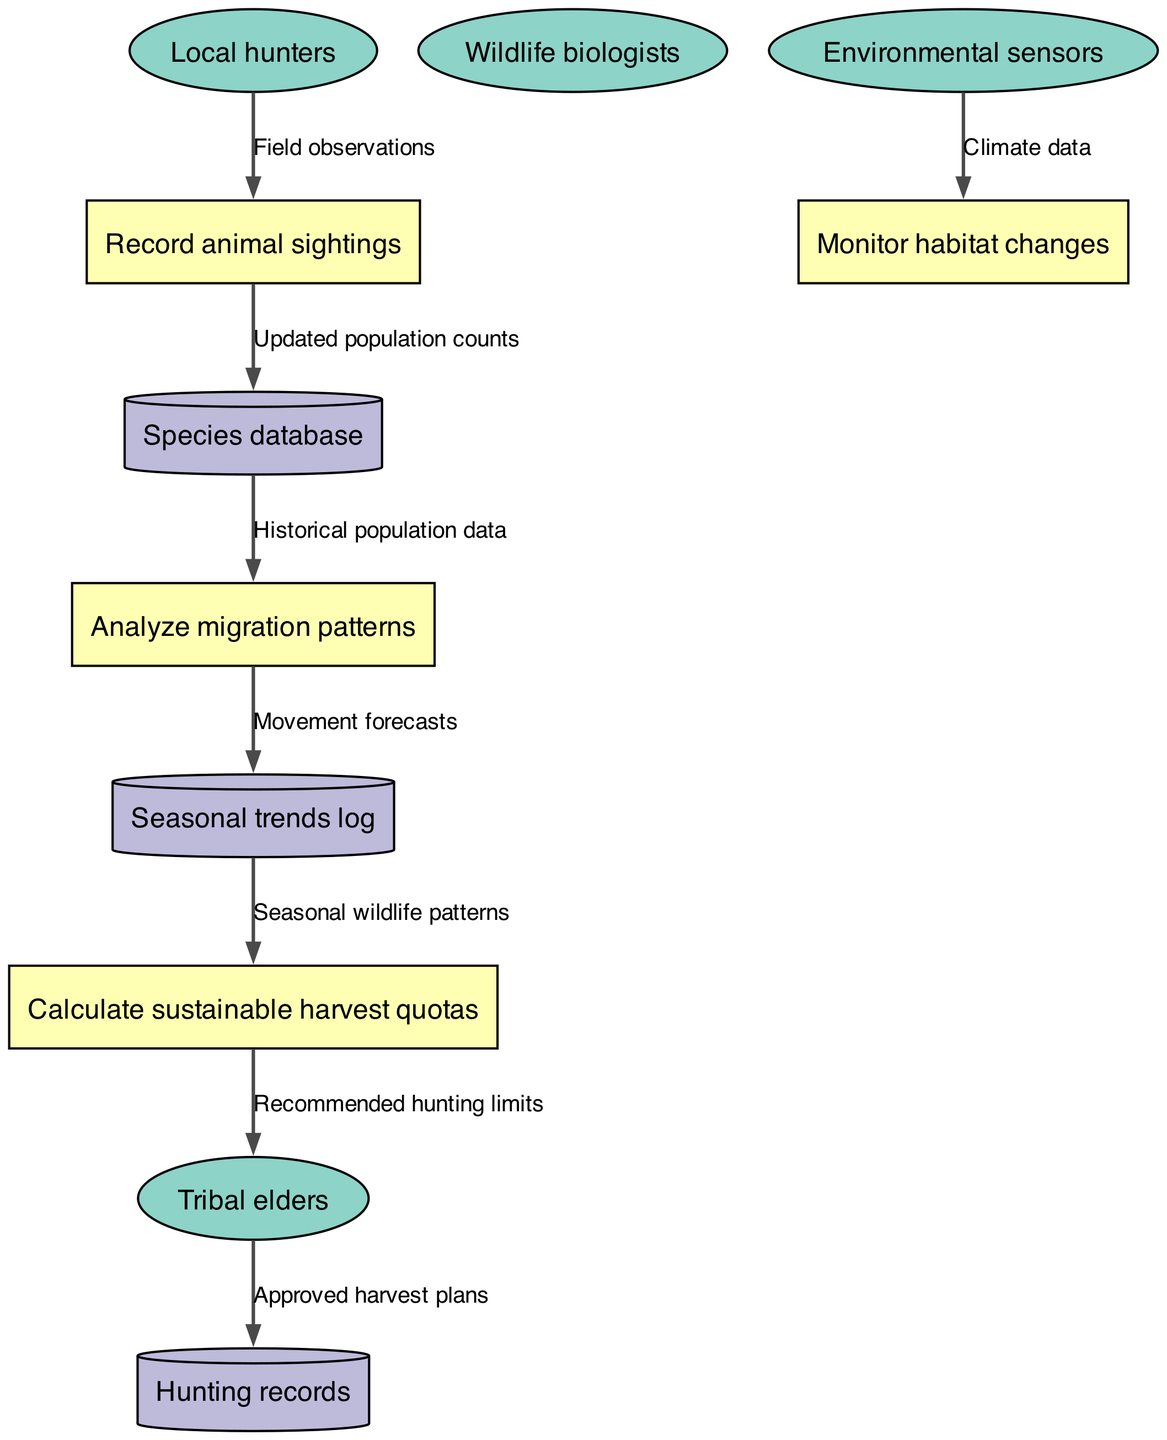What are the external entities in the diagram? The external entities are listed in the diagram. They include Local hunters, Tribal elders, Wildlife biologists, and Environmental sensors.
Answer: Local hunters, Tribal elders, Wildlife biologists, Environmental sensors How many processes are represented in the diagram? The diagram lists four processes: Record animal sightings, Analyze migration patterns, Monitor habitat changes, and Calculate sustainable harvest quotas. Therefore, the number of processes is four.
Answer: Four What data flows from Local hunters to Record animal sightings? The data flow from Local hunters to Record animal sightings is labeled as Field observations, indicating the type of data being shared.
Answer: Field observations Which process sends data to the Species database? The process that sends data to the Species database is Record animal sightings, which updates the population counts based on animal sightings recorded.
Answer: Record animal sightings What is the final output sent to Tribal elders? The final output sent to Tribal elders is the Recommended hunting limits, which are calculated from previous processes regarding sustainable harvest quotas.
Answer: Recommended hunting limits What data flow connects Analyze migration patterns to Seasonal trends log? The data flow connecting Analyze migration patterns to Seasonal trends log is labeled Movement forecasts, indicating the type of information being transferred based on the analysis of migration patterns.
Answer: Movement forecasts Explain the overall objective of the wildlife population monitoring system. The overall objective of the system is to integrate various data inputs such as field observations and sensor data to analyze and manage wildlife populations sustainably, ultimately leading to recommended hunting limits for tribal elders.
Answer: Sustainable wildlife management How does climate data influence the monitoring process? Climate data is collected from environmental sensors and is utilized in the process Monitor habitat changes, which contributes to a better understanding of wildlife habitats and their changes over time, aiding in various monitoring decisions.
Answer: Monitor habitat changes What type of database is used to store historical population data? The type of database used to store historical population data is the Species database, which collects updated population counts based on animal sightings.
Answer: Species database 